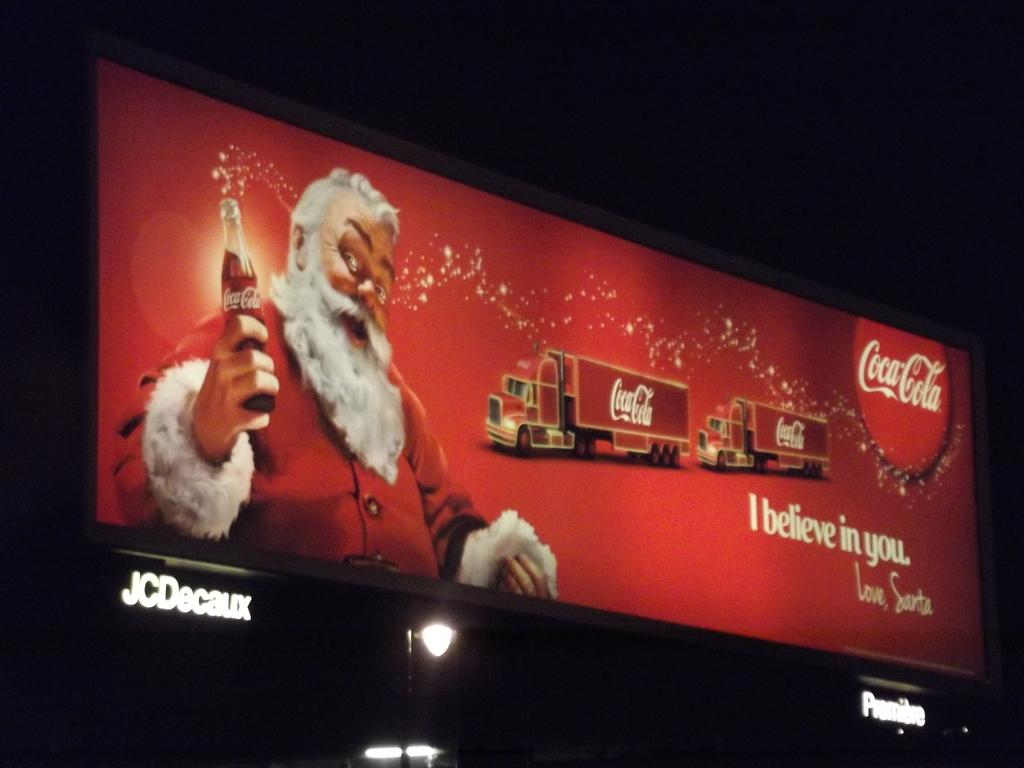<image>
Offer a succinct explanation of the picture presented. a sign that says I believe in you on it 